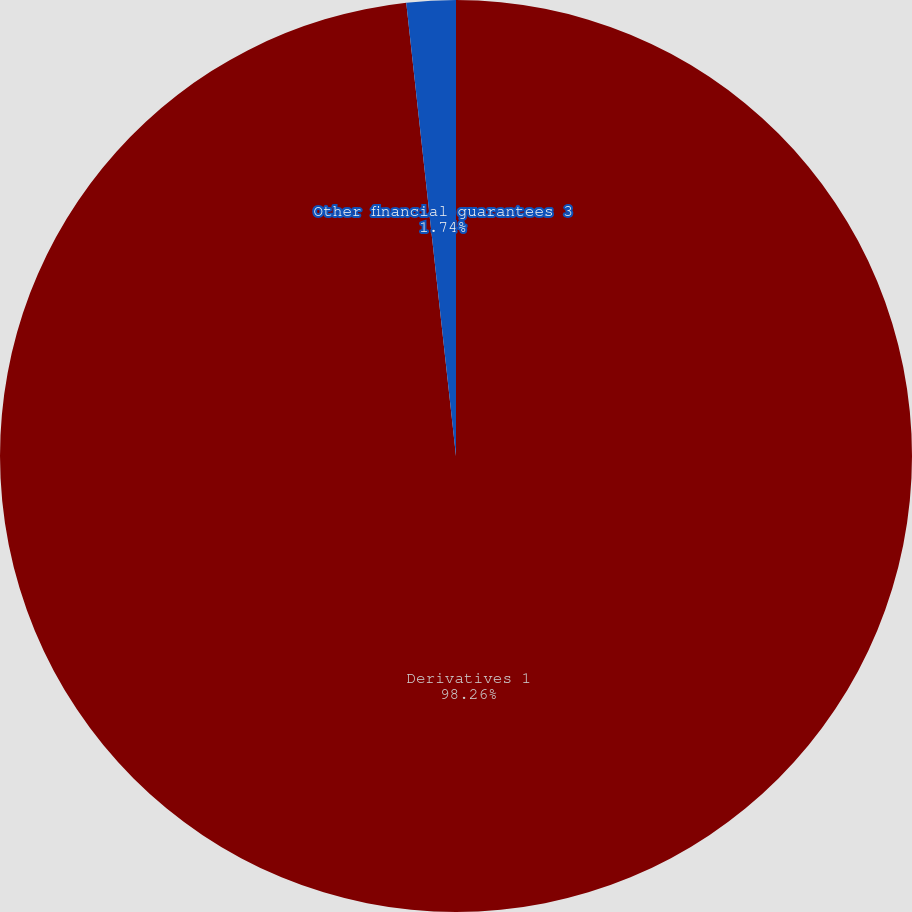Convert chart. <chart><loc_0><loc_0><loc_500><loc_500><pie_chart><fcel>Derivatives 1<fcel>Other financial guarantees 3<nl><fcel>98.26%<fcel>1.74%<nl></chart> 